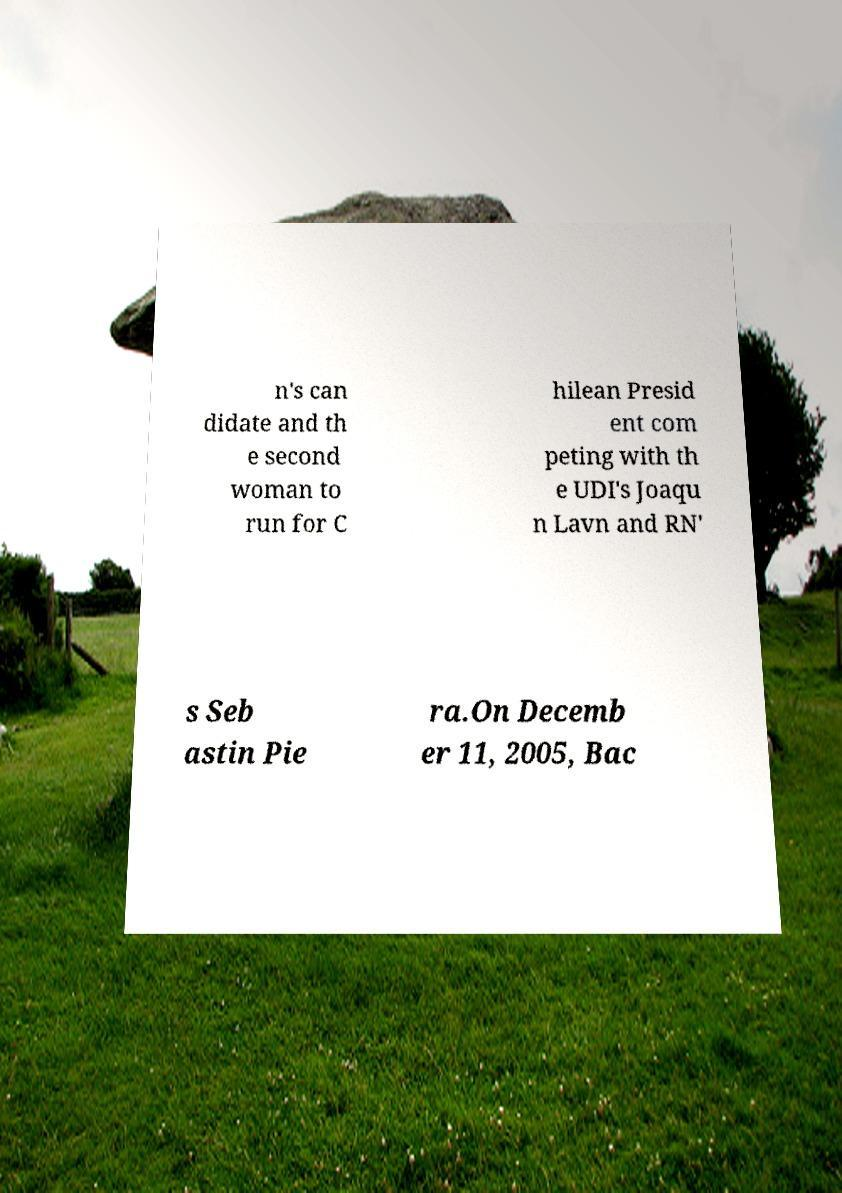For documentation purposes, I need the text within this image transcribed. Could you provide that? n's can didate and th e second woman to run for C hilean Presid ent com peting with th e UDI's Joaqu n Lavn and RN' s Seb astin Pie ra.On Decemb er 11, 2005, Bac 